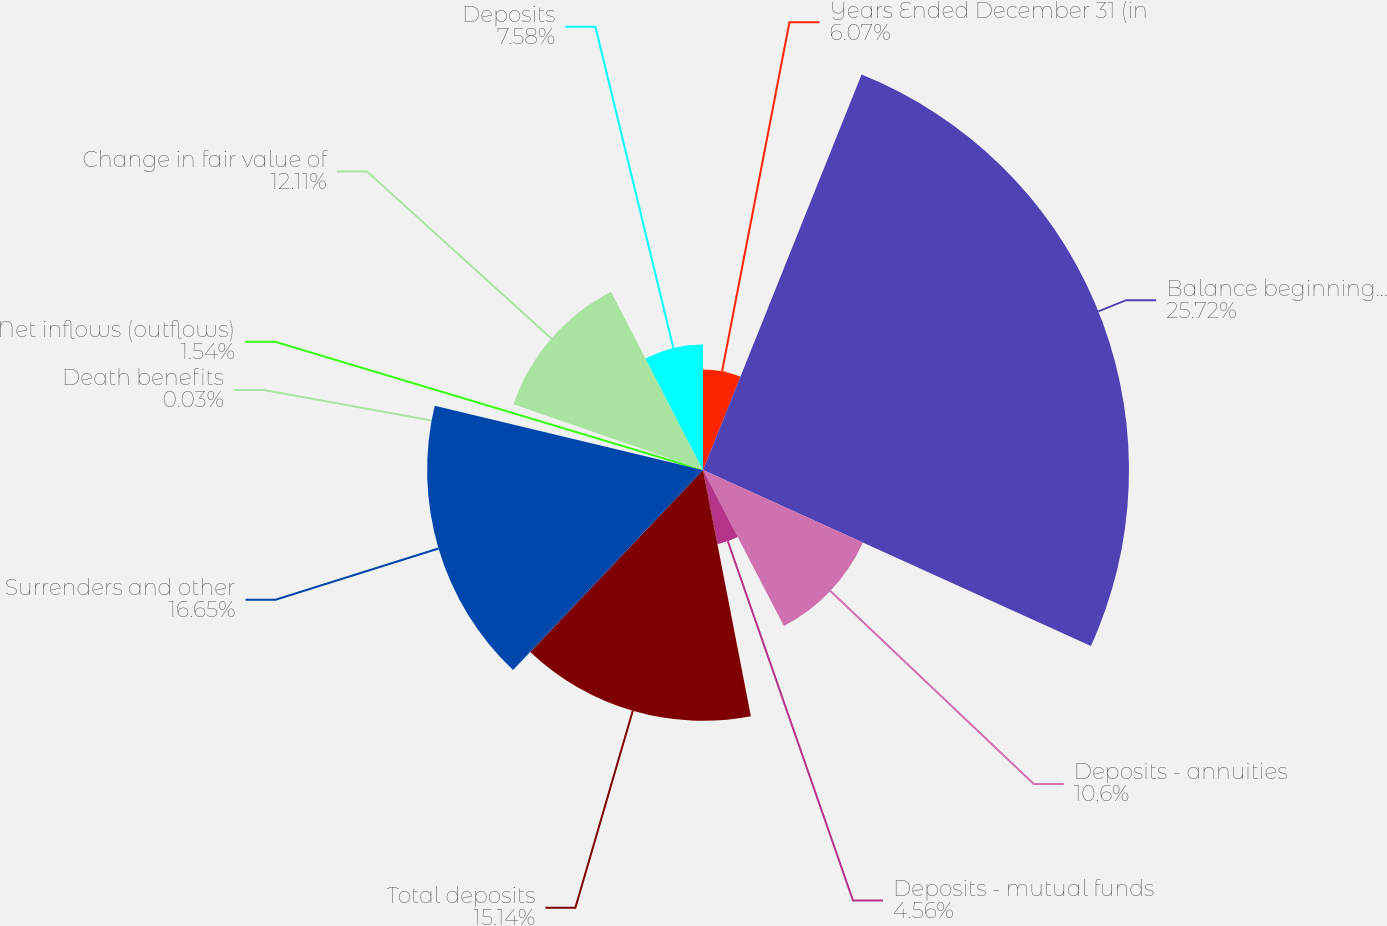<chart> <loc_0><loc_0><loc_500><loc_500><pie_chart><fcel>Years Ended December 31 (in<fcel>Balance beginning of year<fcel>Deposits - annuities<fcel>Deposits - mutual funds<fcel>Total deposits<fcel>Surrenders and other<fcel>Death benefits<fcel>Net inflows (outflows)<fcel>Change in fair value of<fcel>Deposits<nl><fcel>6.07%<fcel>25.71%<fcel>10.6%<fcel>4.56%<fcel>15.14%<fcel>16.65%<fcel>0.03%<fcel>1.54%<fcel>12.11%<fcel>7.58%<nl></chart> 